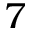Convert formula to latex. <formula><loc_0><loc_0><loc_500><loc_500>7</formula> 